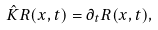<formula> <loc_0><loc_0><loc_500><loc_500>\hat { K } R ( { x } , t ) = \partial _ { t } R ( { x } , t ) ,</formula> 